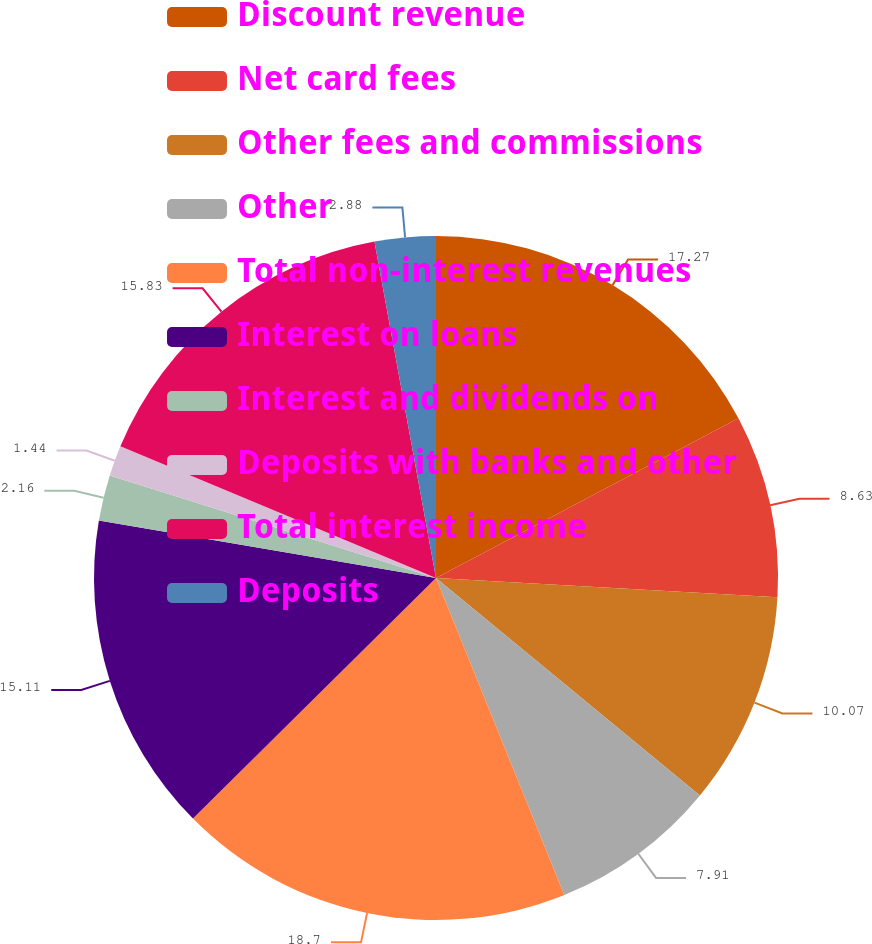<chart> <loc_0><loc_0><loc_500><loc_500><pie_chart><fcel>Discount revenue<fcel>Net card fees<fcel>Other fees and commissions<fcel>Other<fcel>Total non-interest revenues<fcel>Interest on loans<fcel>Interest and dividends on<fcel>Deposits with banks and other<fcel>Total interest income<fcel>Deposits<nl><fcel>17.27%<fcel>8.63%<fcel>10.07%<fcel>7.91%<fcel>18.7%<fcel>15.11%<fcel>2.16%<fcel>1.44%<fcel>15.83%<fcel>2.88%<nl></chart> 